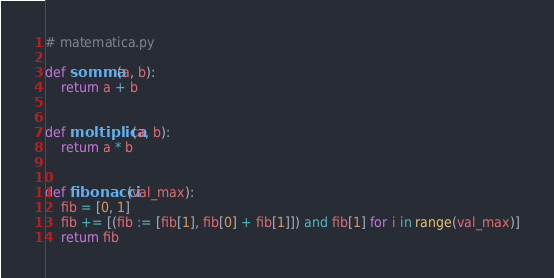<code> <loc_0><loc_0><loc_500><loc_500><_Python_># matematica.py

def somma(a, b):
	return a + b


def moltiplica(a, b):
	return a * b


def fibonacci(val_max):
	fib = [0, 1]
	fib += [(fib := [fib[1], fib[0] + fib[1]]) and fib[1] for i in range(val_max)]
	return fib</code> 